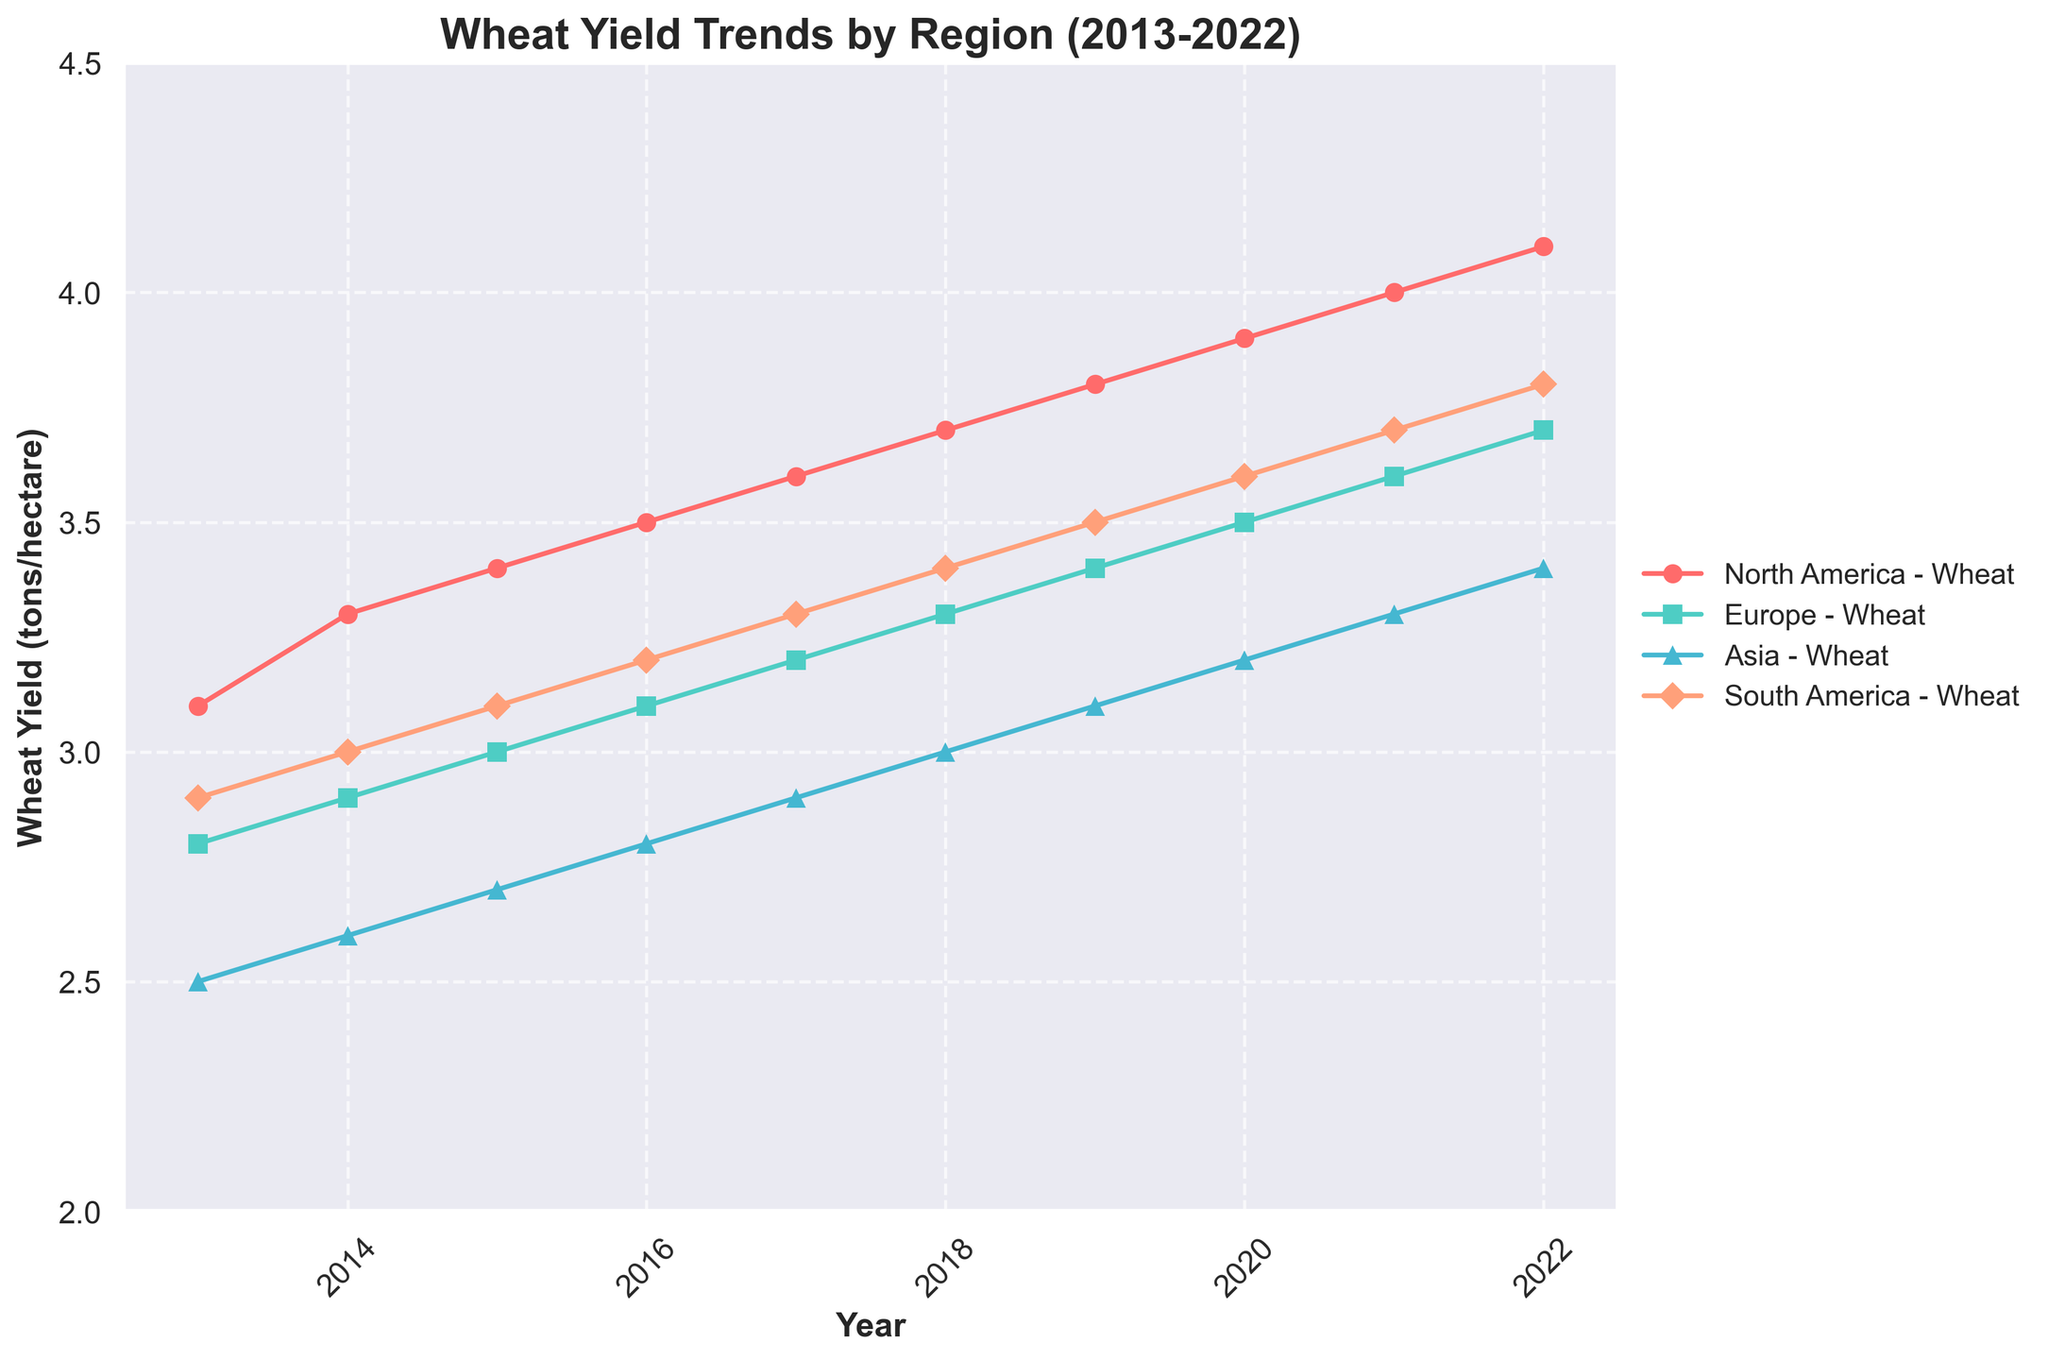What's the title of the figure? The title is displayed at the top of the figure. It reads "Wheat Yield Trends by Region (2013-2022)".
Answer: Wheat Yield Trends by Region (2013-2022) What is the range of the y-axis? The y-axis represents the wheat yield in tons/hectare and ranges from 2 to 4.5. This can be observed by looking at the labeling on the y-axis.
Answer: 2 to 4.5 Which region shows the highest wheat yield in 2022? By examining the endpoints of the lines on the graph for the year 2022, North America has the highest wheat yield.
Answer: North America How many data points are there for each region? Each region has data points for each year from 2013 to 2022. Counting the points for any region will give 10 data points.
Answer: 10 What color represents Europe on the plot? Europe is represented by the second color in the series, which is a teal-like color.
Answer: Teal Which region had the lowest wheat yield in 2013? By looking at the points for the year 2013, Asia shows the lowest yield with a point at 2.5 tons/hectare.
Answer: Asia Did any regions have a decrease in yield at any point between 2013 and 2022? Examining the trends, none of the lines for any region dip; they all consistently increase over time.
Answer: No By how much did the wheat yield in North America increase from 2013 to 2022? Subtract the yield in 2013 from the yield in 2022 for North America: 4.1 - 3.1 = 1.0 tons/hectare.
Answer: 1.0 tons/hectare Between 2017 and 2018, which region had the largest increase in wheat yield? By comparing the increase in vertical positions between the points for 2017 and 2018, North America shows the largest increase.
Answer: North America What is the average wheat yield for Asia between 2013 and 2022? Adding up the yield values for Asia from 2013 to 2022 and dividing by the number of years (10) will give the average. (2.5+2.6+2.7+2.8+2.9+3.0+3.1+3.2+3.3+3.4) / 10 = 2.95 tons/hectare.
Answer: 2.95 tons/hectare 